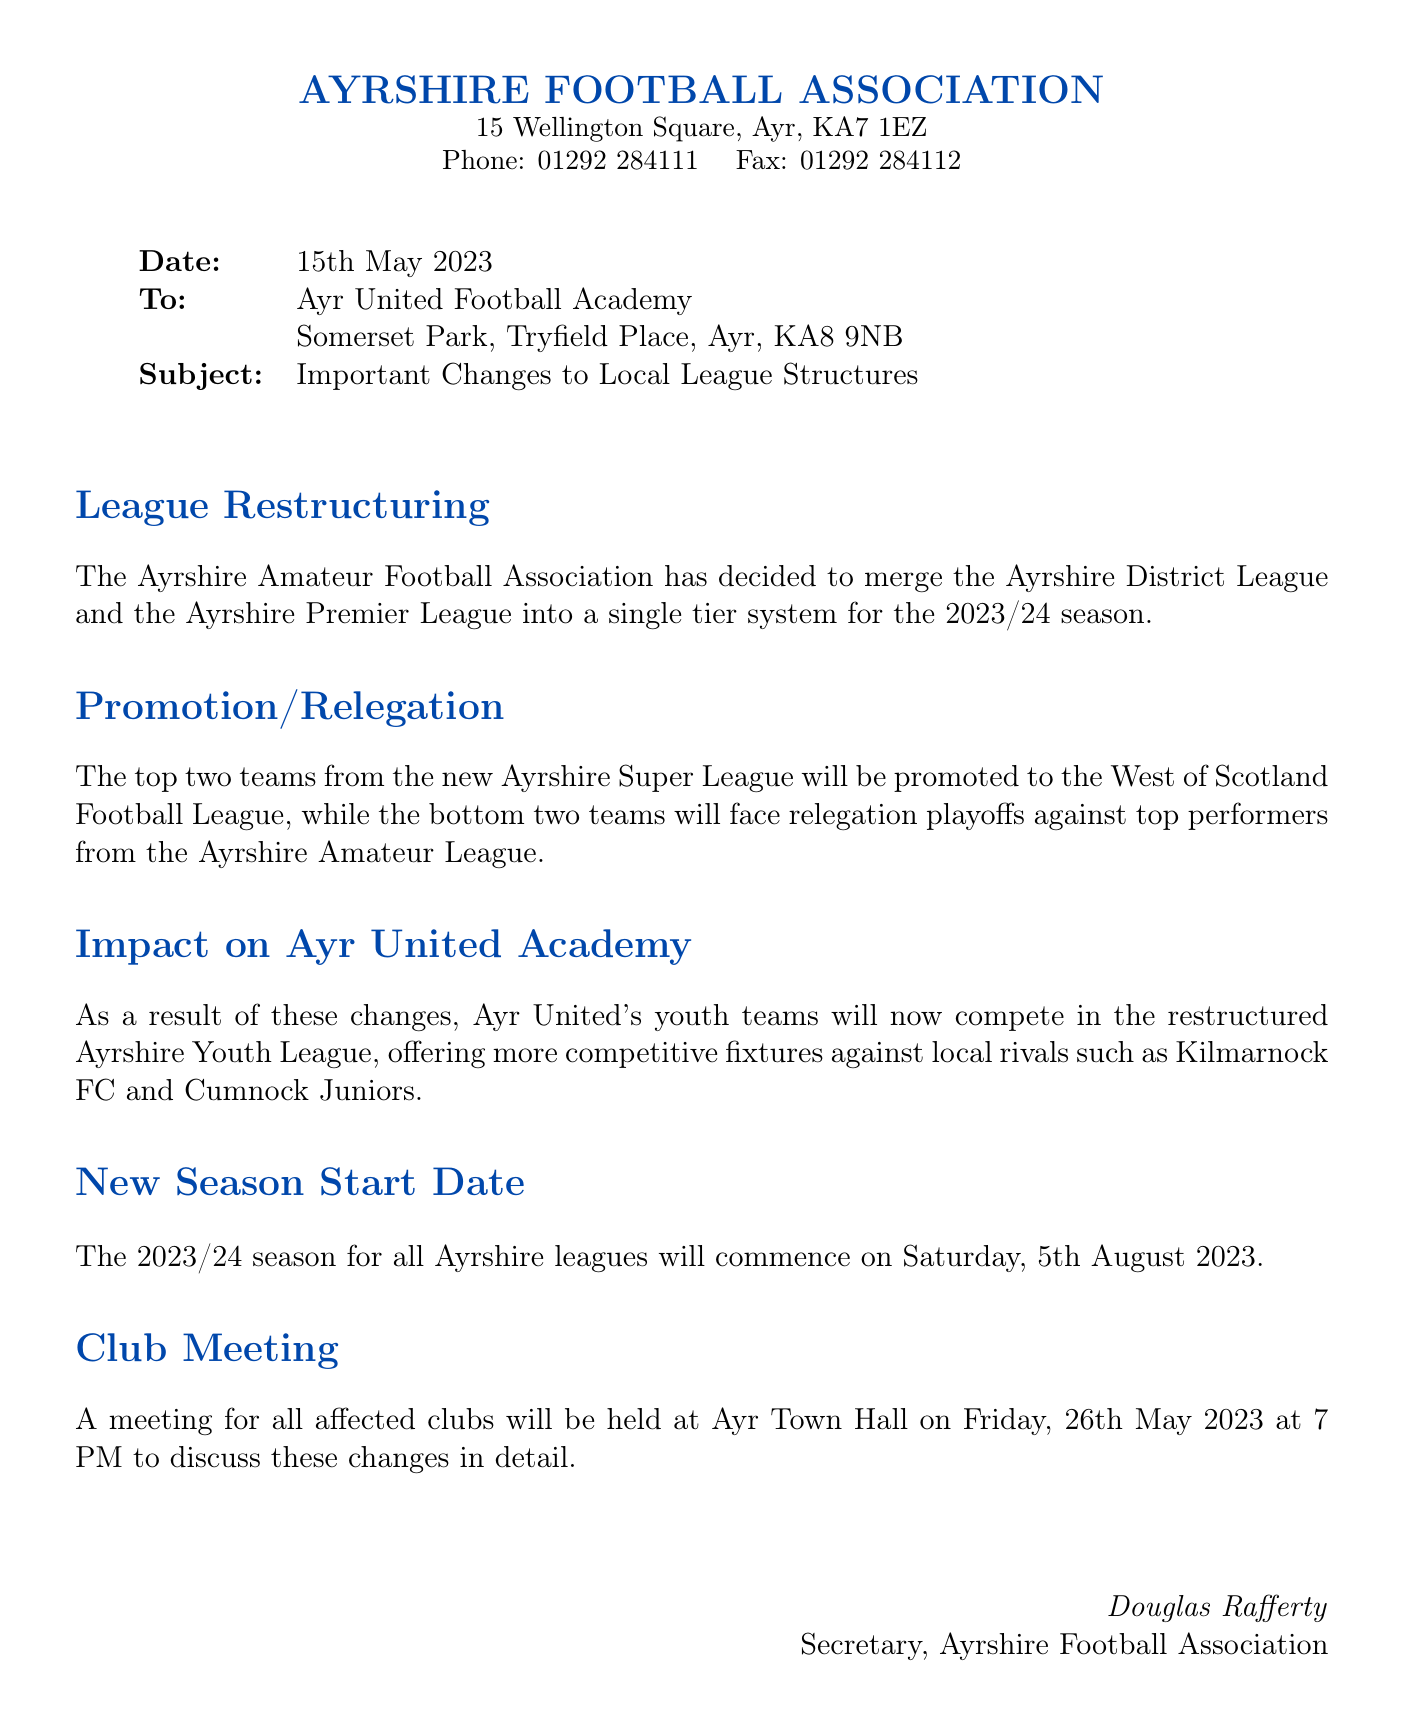what is the date of the fax? The date of the fax is specified in the document header, which states "Date: 15th May 2023".
Answer: 15th May 2023 who is the sender of the fax? The fax indicates the sender at the bottom where it says "Douglas Rafferty, Secretary, Ayrshire Football Association".
Answer: Douglas Rafferty what is the subject of the fax? The subject is clearly labeled in the document as "Important Changes to Local League Structures".
Answer: Important Changes to Local League Structures when does the new season start? The document states that the new season for all Ayrshire leagues will commence on "Saturday, 5th August 2023".
Answer: Saturday, 5th August 2023 where will the club meeting be held? The document specifies the location of the meeting as "Ayr Town Hall".
Answer: Ayr Town Hall how many teams will be promoted to the West of Scotland Football League? The document mentions that "The top two teams from the new Ayrshire Super League will be promoted".
Answer: Two teams what league will Ayr United's youth teams compete in? It is mentioned in the document that Ayr United's youth teams will compete in "the restructured Ayrshire Youth League".
Answer: Ayrshire Youth League when is the club meeting scheduled? The document states the meeting is scheduled for "Friday, 26th May 2023 at 7 PM".
Answer: Friday, 26th May 2023 at 7 PM what leagues are being merged? The document specifies that "the Ayrshire District League and the Ayrshire Premier League" are being merged.
Answer: Ayrshire District League and Ayrshire Premier League 